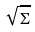Convert formula to latex. <formula><loc_0><loc_0><loc_500><loc_500>\sqrt { \Sigma }</formula> 